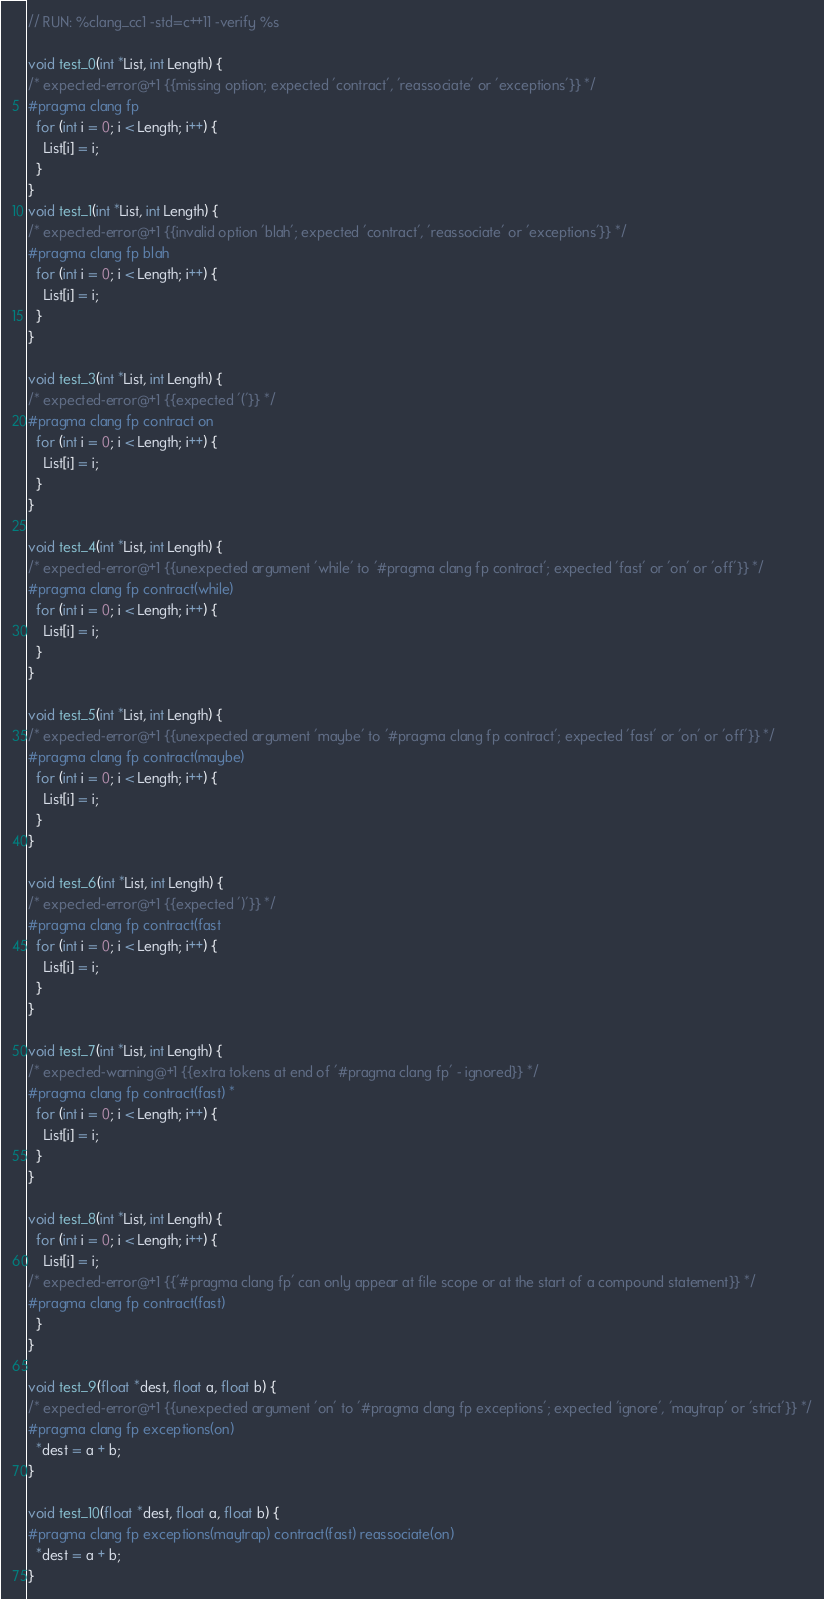Convert code to text. <code><loc_0><loc_0><loc_500><loc_500><_C++_>// RUN: %clang_cc1 -std=c++11 -verify %s

void test_0(int *List, int Length) {
/* expected-error@+1 {{missing option; expected 'contract', 'reassociate' or 'exceptions'}} */
#pragma clang fp
  for (int i = 0; i < Length; i++) {
    List[i] = i;
  }
}
void test_1(int *List, int Length) {
/* expected-error@+1 {{invalid option 'blah'; expected 'contract', 'reassociate' or 'exceptions'}} */
#pragma clang fp blah
  for (int i = 0; i < Length; i++) {
    List[i] = i;
  }
}

void test_3(int *List, int Length) {
/* expected-error@+1 {{expected '('}} */
#pragma clang fp contract on
  for (int i = 0; i < Length; i++) {
    List[i] = i;
  }
}

void test_4(int *List, int Length) {
/* expected-error@+1 {{unexpected argument 'while' to '#pragma clang fp contract'; expected 'fast' or 'on' or 'off'}} */
#pragma clang fp contract(while)
  for (int i = 0; i < Length; i++) {
    List[i] = i;
  }
}

void test_5(int *List, int Length) {
/* expected-error@+1 {{unexpected argument 'maybe' to '#pragma clang fp contract'; expected 'fast' or 'on' or 'off'}} */
#pragma clang fp contract(maybe)
  for (int i = 0; i < Length; i++) {
    List[i] = i;
  }
}

void test_6(int *List, int Length) {
/* expected-error@+1 {{expected ')'}} */
#pragma clang fp contract(fast
  for (int i = 0; i < Length; i++) {
    List[i] = i;
  }
}

void test_7(int *List, int Length) {
/* expected-warning@+1 {{extra tokens at end of '#pragma clang fp' - ignored}} */
#pragma clang fp contract(fast) *
  for (int i = 0; i < Length; i++) {
    List[i] = i;
  }
}

void test_8(int *List, int Length) {
  for (int i = 0; i < Length; i++) {
    List[i] = i;
/* expected-error@+1 {{'#pragma clang fp' can only appear at file scope or at the start of a compound statement}} */
#pragma clang fp contract(fast)
  }
}

void test_9(float *dest, float a, float b) {
/* expected-error@+1 {{unexpected argument 'on' to '#pragma clang fp exceptions'; expected 'ignore', 'maytrap' or 'strict'}} */
#pragma clang fp exceptions(on)
  *dest = a + b;
}

void test_10(float *dest, float a, float b) {
#pragma clang fp exceptions(maytrap) contract(fast) reassociate(on)
  *dest = a + b;
}
</code> 